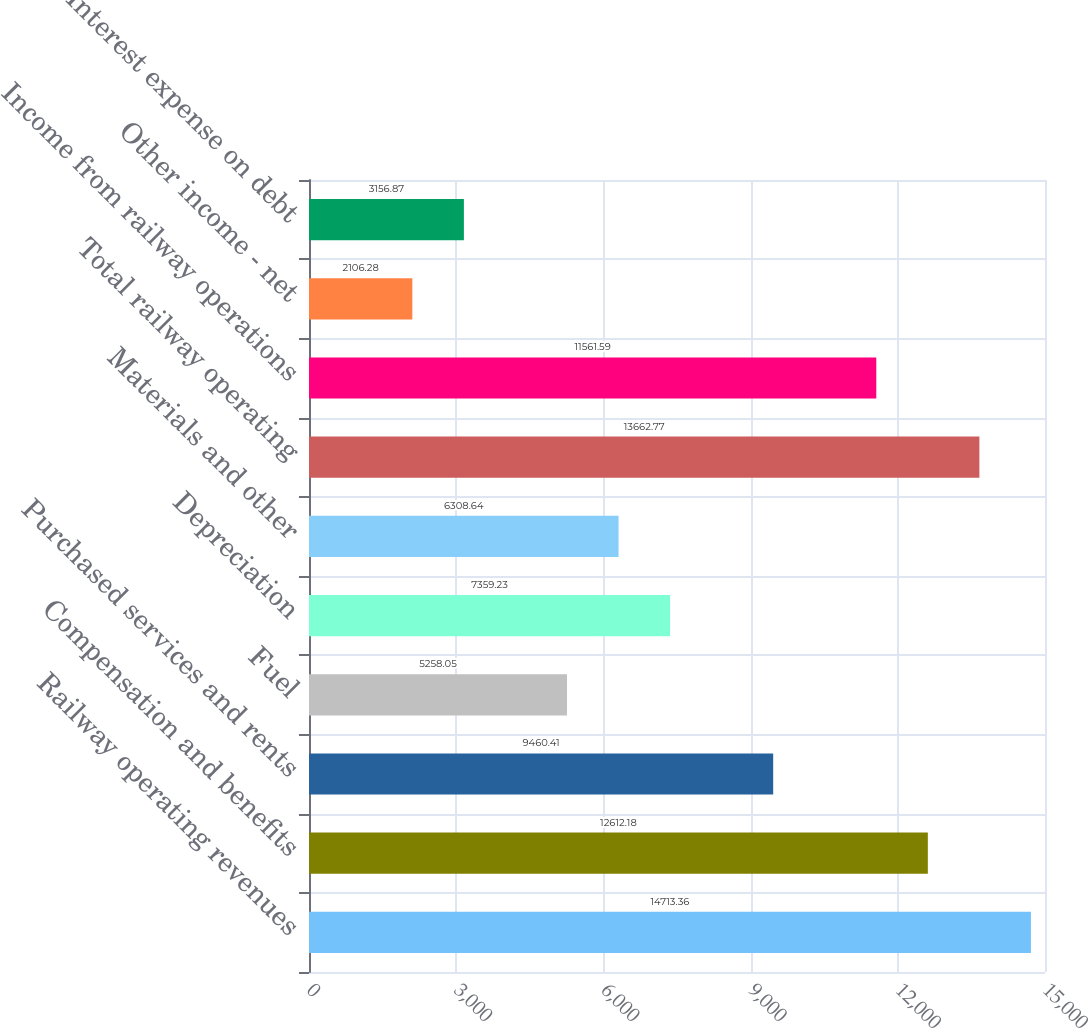Convert chart. <chart><loc_0><loc_0><loc_500><loc_500><bar_chart><fcel>Railway operating revenues<fcel>Compensation and benefits<fcel>Purchased services and rents<fcel>Fuel<fcel>Depreciation<fcel>Materials and other<fcel>Total railway operating<fcel>Income from railway operations<fcel>Other income - net<fcel>Interest expense on debt<nl><fcel>14713.4<fcel>12612.2<fcel>9460.41<fcel>5258.05<fcel>7359.23<fcel>6308.64<fcel>13662.8<fcel>11561.6<fcel>2106.28<fcel>3156.87<nl></chart> 